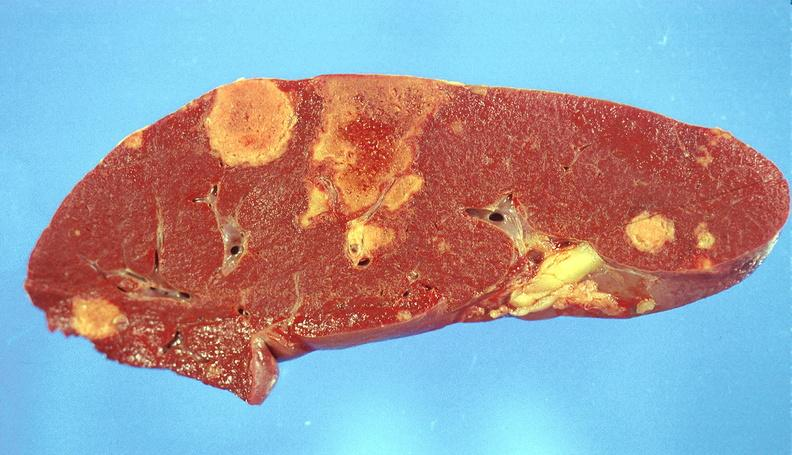where is this part in?
Answer the question using a single word or phrase. Spleen 